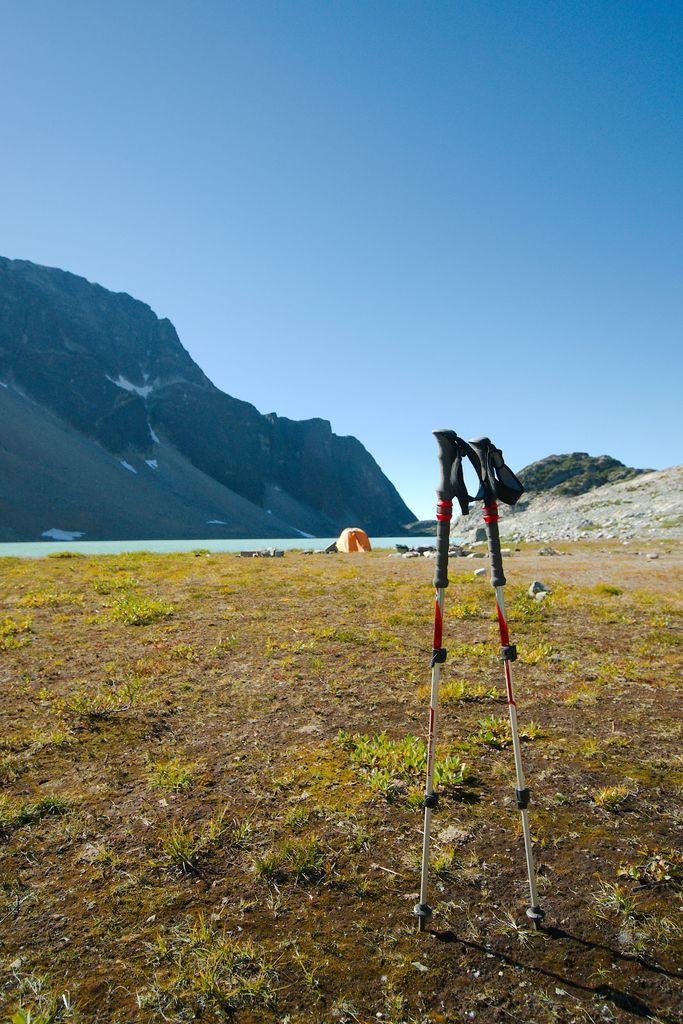What objects are on the ground in the image? There are two sticks on the ground in the image. What can be seen in the distance in the image? There is a mountain and water visible in the background of the image. What is located near the water in the background? There is an object near the water in the background. What part of the natural environment is visible in the image? The sky is visible in the background of the image. What invention is the queen using in the image? There is no queen or invention present in the image. 